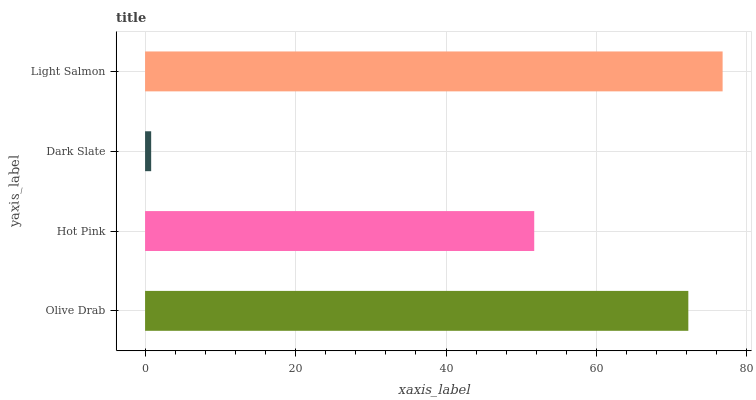Is Dark Slate the minimum?
Answer yes or no. Yes. Is Light Salmon the maximum?
Answer yes or no. Yes. Is Hot Pink the minimum?
Answer yes or no. No. Is Hot Pink the maximum?
Answer yes or no. No. Is Olive Drab greater than Hot Pink?
Answer yes or no. Yes. Is Hot Pink less than Olive Drab?
Answer yes or no. Yes. Is Hot Pink greater than Olive Drab?
Answer yes or no. No. Is Olive Drab less than Hot Pink?
Answer yes or no. No. Is Olive Drab the high median?
Answer yes or no. Yes. Is Hot Pink the low median?
Answer yes or no. Yes. Is Hot Pink the high median?
Answer yes or no. No. Is Dark Slate the low median?
Answer yes or no. No. 